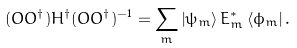Convert formula to latex. <formula><loc_0><loc_0><loc_500><loc_500>( O O ^ { \dagger } ) H ^ { \dagger } ( O O ^ { \dagger } ) ^ { - 1 } = \sum _ { m } \left | \psi _ { m } \right \rangle E _ { m } ^ { \ast } \left \langle \phi _ { m } \right | .</formula> 